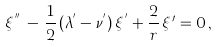<formula> <loc_0><loc_0><loc_500><loc_500>\xi ^ { ^ { \prime \prime } } \, - \, \frac { 1 } { 2 } \, ( \lambda ^ { ^ { \prime } } - \nu ^ { ^ { \prime } } ) \, \xi ^ { ^ { \prime } } + \frac { 2 } { r } \, \xi { ^ { \prime } } = 0 \, ,</formula> 